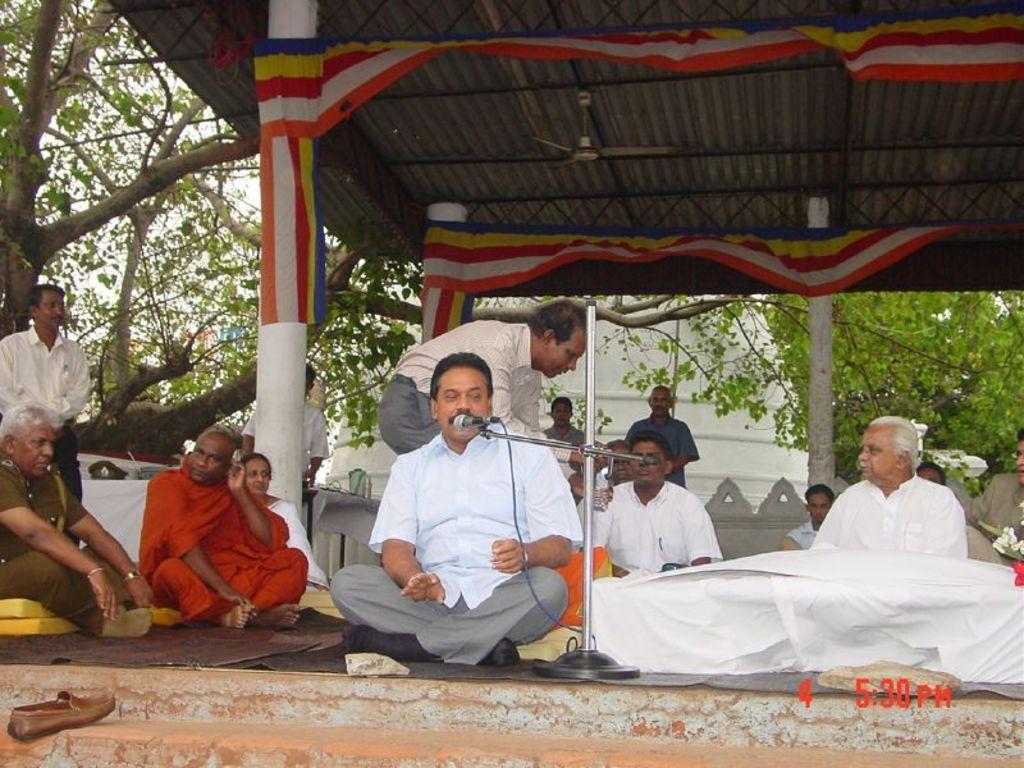Could you give a brief overview of what you see in this image? In this image there are a group of people who are sitting, in the foreground the person who is sitting and he is talking. In front of him there is mike and stand, and in the background there are some people standing and also some trees and building. At the top there is ceiling and some poles and fan and also some pillars. On the pillars there is some cloth, at the bottom there is staircase and a shoe. 